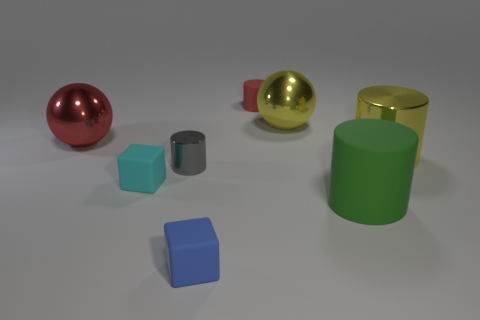Add 2 cyan blocks. How many objects exist? 10 Subtract all cubes. How many objects are left? 6 Add 3 large yellow rubber cubes. How many large yellow rubber cubes exist? 3 Subtract 1 yellow balls. How many objects are left? 7 Subtract all tiny metallic balls. Subtract all big yellow shiny balls. How many objects are left? 7 Add 3 cyan matte objects. How many cyan matte objects are left? 4 